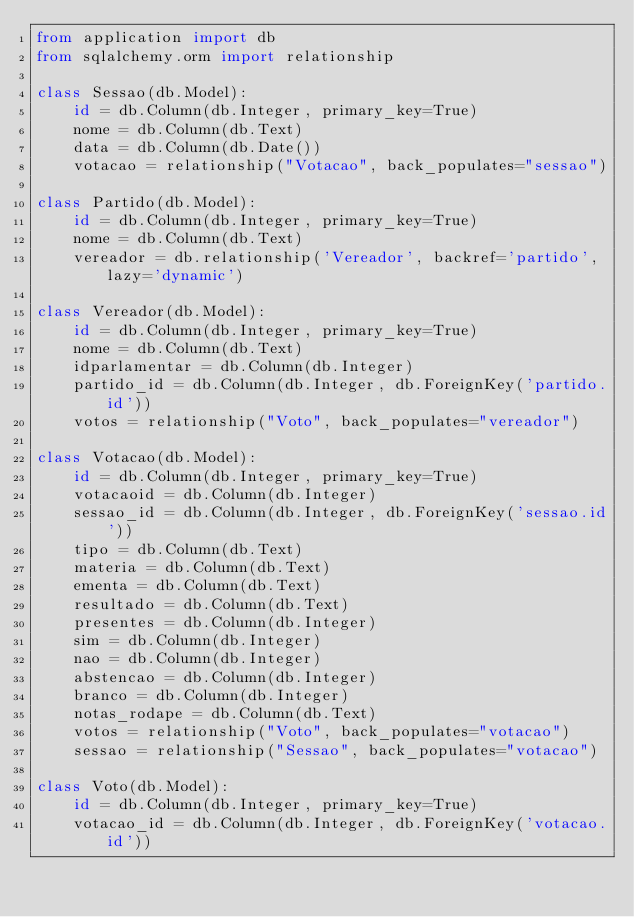Convert code to text. <code><loc_0><loc_0><loc_500><loc_500><_Python_>from application import db
from sqlalchemy.orm import relationship

class Sessao(db.Model):
    id = db.Column(db.Integer, primary_key=True)
    nome = db.Column(db.Text)
    data = db.Column(db.Date())
    votacao = relationship("Votacao", back_populates="sessao")

class Partido(db.Model):
    id = db.Column(db.Integer, primary_key=True)
    nome = db.Column(db.Text)
    vereador = db.relationship('Vereador', backref='partido', lazy='dynamic')

class Vereador(db.Model):
    id = db.Column(db.Integer, primary_key=True)
    nome = db.Column(db.Text)
    idparlamentar = db.Column(db.Integer)
    partido_id = db.Column(db.Integer, db.ForeignKey('partido.id'))
    votos = relationship("Voto", back_populates="vereador")

class Votacao(db.Model):
    id = db.Column(db.Integer, primary_key=True)
    votacaoid = db.Column(db.Integer)
    sessao_id = db.Column(db.Integer, db.ForeignKey('sessao.id'))
    tipo = db.Column(db.Text)
    materia = db.Column(db.Text)
    ementa = db.Column(db.Text)
    resultado = db.Column(db.Text)
    presentes = db.Column(db.Integer)
    sim = db.Column(db.Integer)
    nao = db.Column(db.Integer)
    abstencao = db.Column(db.Integer)
    branco = db.Column(db.Integer)
    notas_rodape = db.Column(db.Text)
    votos = relationship("Voto", back_populates="votacao")
    sessao = relationship("Sessao", back_populates="votacao")

class Voto(db.Model):
    id = db.Column(db.Integer, primary_key=True)
    votacao_id = db.Column(db.Integer, db.ForeignKey('votacao.id'))</code> 